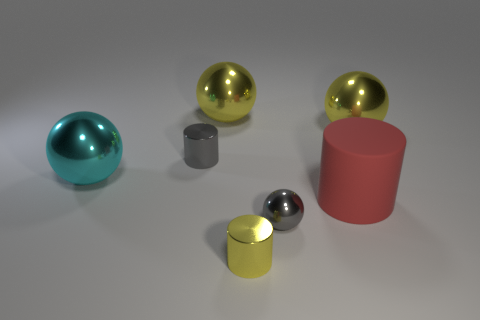There is a small object that is the same shape as the big cyan metal object; what color is it?
Keep it short and to the point. Gray. Are there an equal number of spheres and red cylinders?
Offer a terse response. No. What number of big metal objects are the same shape as the small yellow metallic object?
Provide a short and direct response. 0. What is the material of the object that is the same color as the small shiny ball?
Make the answer very short. Metal. What number of yellow things are there?
Provide a short and direct response. 3. Are there any purple things that have the same material as the large red cylinder?
Your answer should be compact. No. What is the size of the cylinder that is the same color as the small metallic sphere?
Provide a short and direct response. Small. Do the yellow thing in front of the big rubber cylinder and the yellow object to the right of the large rubber cylinder have the same size?
Give a very brief answer. No. There is a yellow metallic thing that is in front of the tiny metallic sphere; what size is it?
Provide a succinct answer. Small. Are there any other shiny balls that have the same color as the small ball?
Ensure brevity in your answer.  No. 